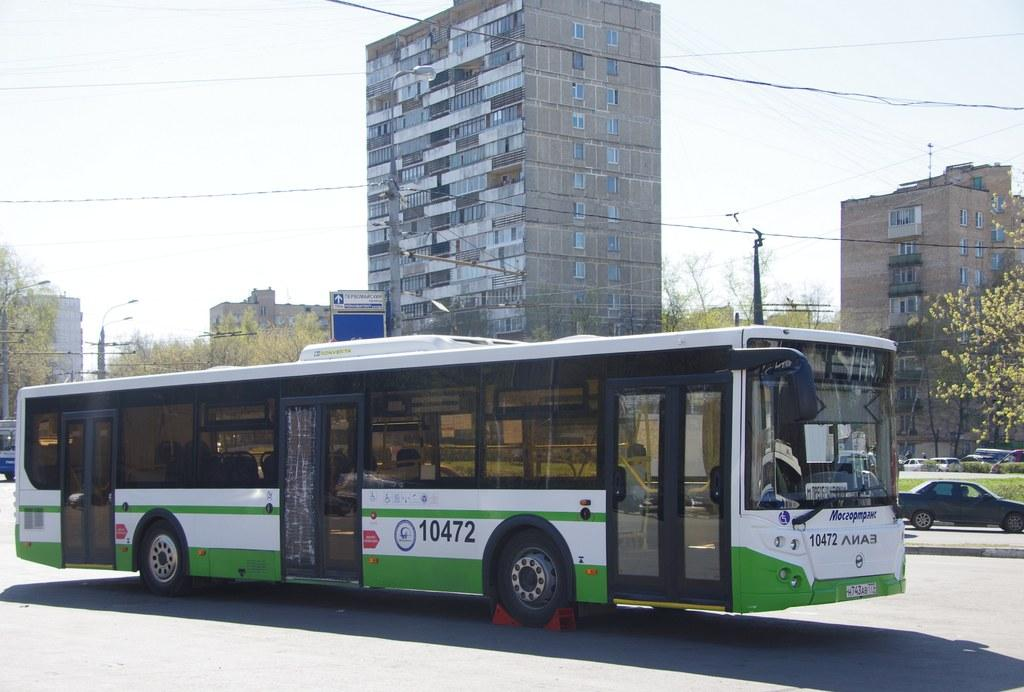Provide a one-sentence caption for the provided image. Bus number 10472 is white with green stripes on the bottom half. 